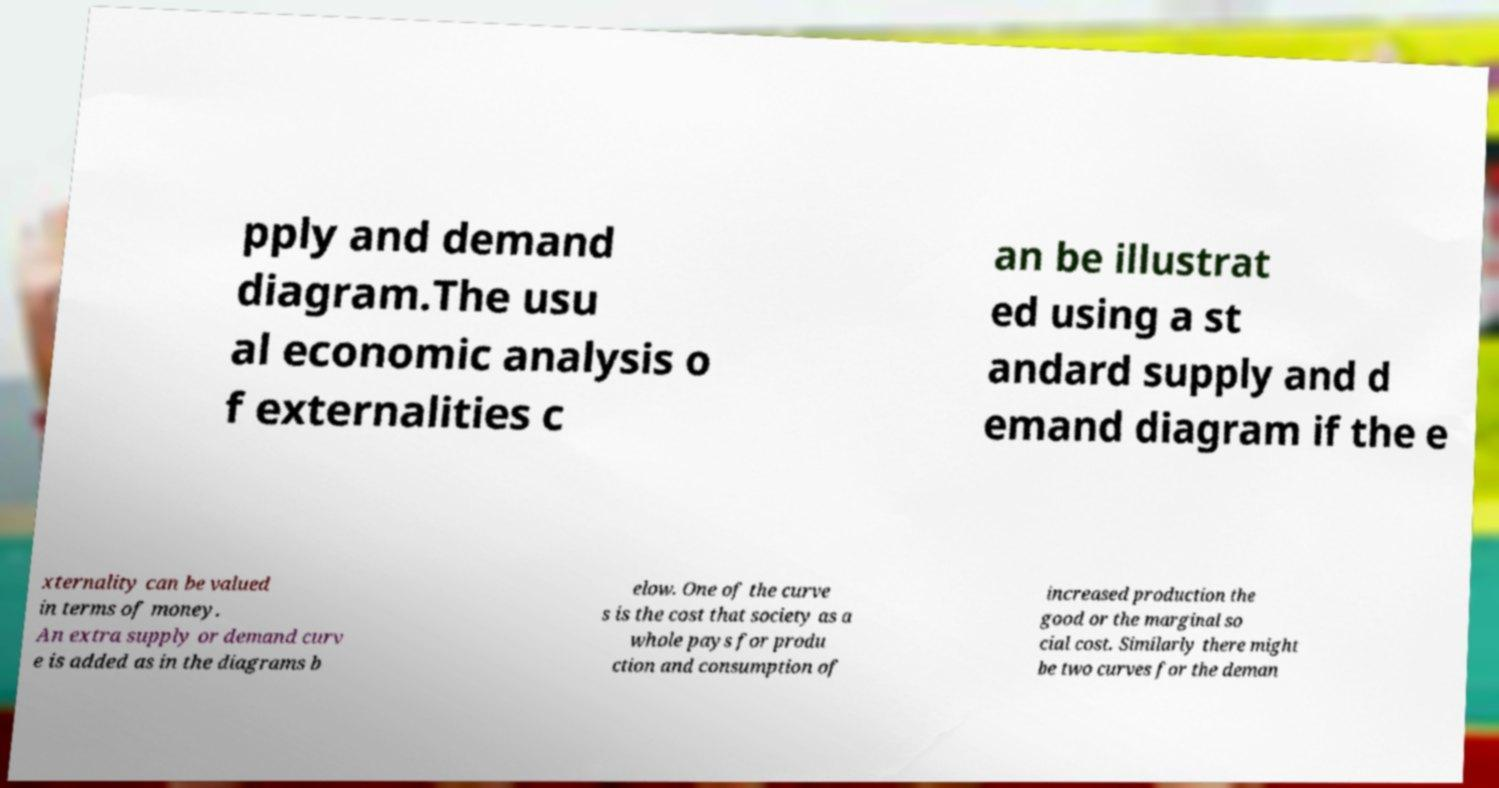I need the written content from this picture converted into text. Can you do that? pply and demand diagram.The usu al economic analysis o f externalities c an be illustrat ed using a st andard supply and d emand diagram if the e xternality can be valued in terms of money. An extra supply or demand curv e is added as in the diagrams b elow. One of the curve s is the cost that society as a whole pays for produ ction and consumption of increased production the good or the marginal so cial cost. Similarly there might be two curves for the deman 